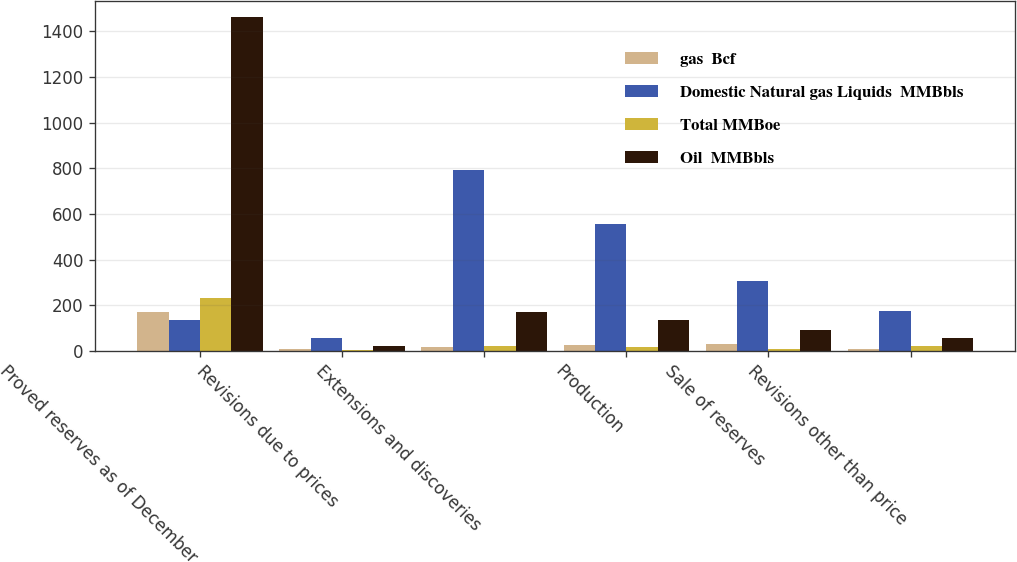Convert chart. <chart><loc_0><loc_0><loc_500><loc_500><stacked_bar_chart><ecel><fcel>Proved reserves as of December<fcel>Revisions due to prices<fcel>Extensions and discoveries<fcel>Production<fcel>Sale of reserves<fcel>Revisions other than price<nl><fcel>gas  Bcf<fcel>170<fcel>6<fcel>16<fcel>25<fcel>29<fcel>6<nl><fcel>Domestic Natural gas Liquids  MMBbls<fcel>136<fcel>58<fcel>793<fcel>555<fcel>306<fcel>174<nl><fcel>Total MMBoe<fcel>233<fcel>3<fcel>20<fcel>18<fcel>9<fcel>21<nl><fcel>Oil  MMBbls<fcel>1462<fcel>19<fcel>169<fcel>136<fcel>89<fcel>56<nl></chart> 